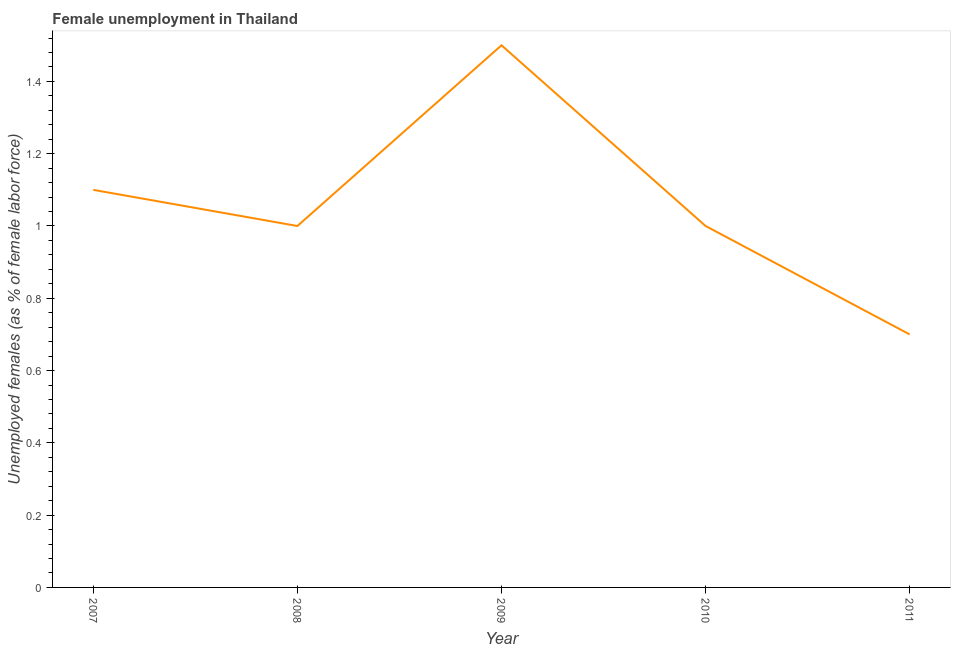What is the unemployed females population in 2010?
Keep it short and to the point. 1. Across all years, what is the maximum unemployed females population?
Provide a succinct answer. 1.5. Across all years, what is the minimum unemployed females population?
Offer a very short reply. 0.7. In which year was the unemployed females population minimum?
Ensure brevity in your answer.  2011. What is the sum of the unemployed females population?
Give a very brief answer. 5.3. What is the average unemployed females population per year?
Keep it short and to the point. 1.06. What is the median unemployed females population?
Your answer should be compact. 1. In how many years, is the unemployed females population greater than 0.8400000000000001 %?
Ensure brevity in your answer.  4. What is the ratio of the unemployed females population in 2007 to that in 2009?
Offer a terse response. 0.73. Is the unemployed females population in 2008 less than that in 2009?
Make the answer very short. Yes. Is the difference between the unemployed females population in 2009 and 2010 greater than the difference between any two years?
Your answer should be very brief. No. What is the difference between the highest and the second highest unemployed females population?
Keep it short and to the point. 0.4. Is the sum of the unemployed females population in 2010 and 2011 greater than the maximum unemployed females population across all years?
Provide a succinct answer. Yes. What is the difference between the highest and the lowest unemployed females population?
Give a very brief answer. 0.8. In how many years, is the unemployed females population greater than the average unemployed females population taken over all years?
Offer a very short reply. 2. Does the unemployed females population monotonically increase over the years?
Offer a terse response. No. How many lines are there?
Make the answer very short. 1. What is the difference between two consecutive major ticks on the Y-axis?
Offer a very short reply. 0.2. Are the values on the major ticks of Y-axis written in scientific E-notation?
Ensure brevity in your answer.  No. What is the title of the graph?
Make the answer very short. Female unemployment in Thailand. What is the label or title of the X-axis?
Give a very brief answer. Year. What is the label or title of the Y-axis?
Ensure brevity in your answer.  Unemployed females (as % of female labor force). What is the Unemployed females (as % of female labor force) of 2007?
Provide a short and direct response. 1.1. What is the Unemployed females (as % of female labor force) in 2011?
Provide a short and direct response. 0.7. What is the difference between the Unemployed females (as % of female labor force) in 2007 and 2008?
Give a very brief answer. 0.1. What is the difference between the Unemployed females (as % of female labor force) in 2007 and 2010?
Provide a succinct answer. 0.1. What is the difference between the Unemployed females (as % of female labor force) in 2008 and 2009?
Give a very brief answer. -0.5. What is the difference between the Unemployed females (as % of female labor force) in 2008 and 2010?
Your response must be concise. 0. What is the difference between the Unemployed females (as % of female labor force) in 2010 and 2011?
Your response must be concise. 0.3. What is the ratio of the Unemployed females (as % of female labor force) in 2007 to that in 2009?
Your answer should be compact. 0.73. What is the ratio of the Unemployed females (as % of female labor force) in 2007 to that in 2011?
Your answer should be very brief. 1.57. What is the ratio of the Unemployed females (as % of female labor force) in 2008 to that in 2009?
Make the answer very short. 0.67. What is the ratio of the Unemployed females (as % of female labor force) in 2008 to that in 2011?
Ensure brevity in your answer.  1.43. What is the ratio of the Unemployed females (as % of female labor force) in 2009 to that in 2011?
Your answer should be compact. 2.14. What is the ratio of the Unemployed females (as % of female labor force) in 2010 to that in 2011?
Keep it short and to the point. 1.43. 